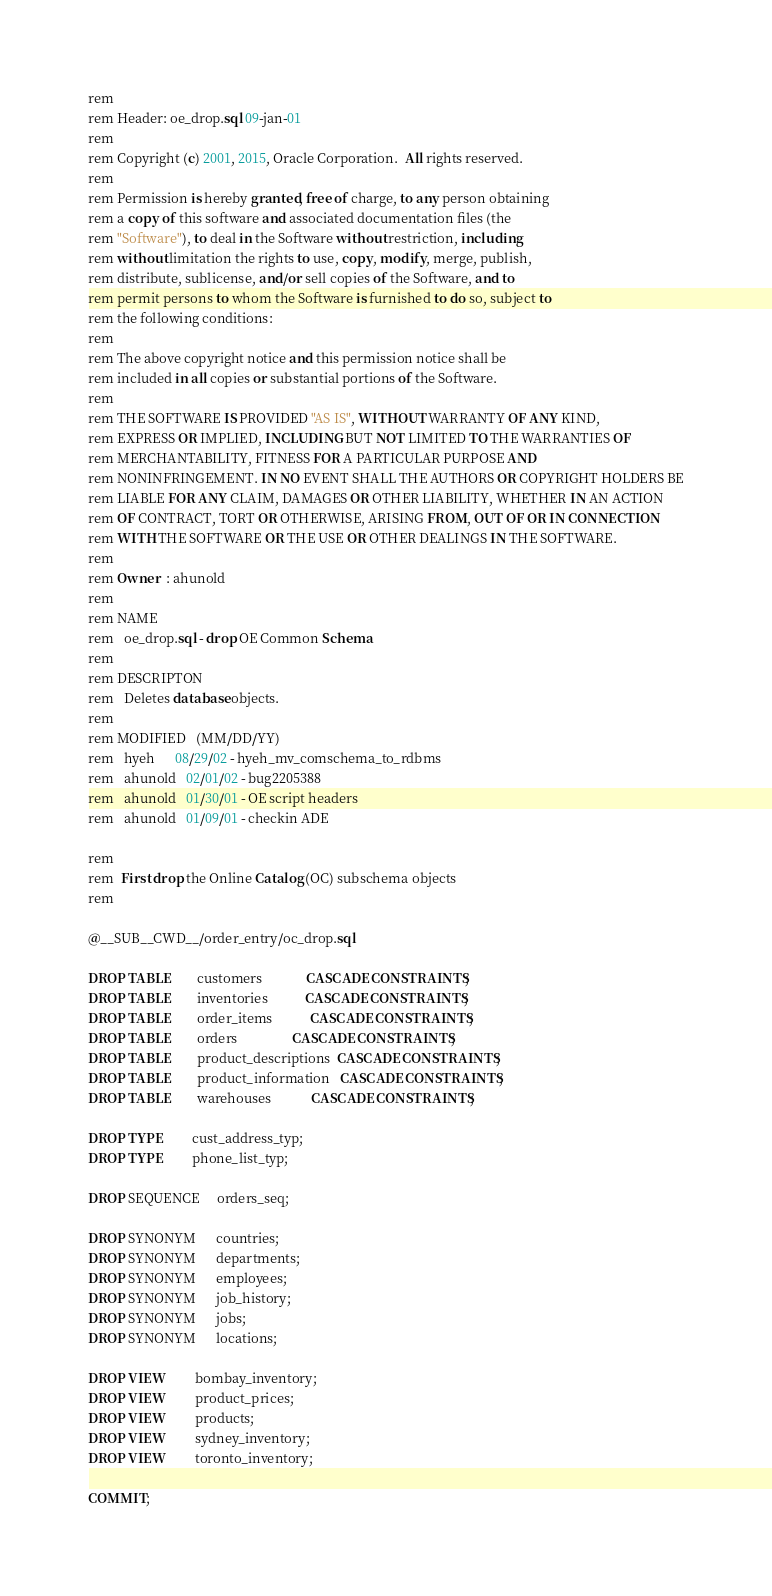Convert code to text. <code><loc_0><loc_0><loc_500><loc_500><_SQL_>rem
rem Header: oe_drop.sql 09-jan-01
rem
rem Copyright (c) 2001, 2015, Oracle Corporation.  All rights reserved.  
rem 
rem Permission is hereby granted, free of charge, to any person obtaining
rem a copy of this software and associated documentation files (the
rem "Software"), to deal in the Software without restriction, including
rem without limitation the rights to use, copy, modify, merge, publish,
rem distribute, sublicense, and/or sell copies of the Software, and to
rem permit persons to whom the Software is furnished to do so, subject to
rem the following conditions:
rem 
rem The above copyright notice and this permission notice shall be
rem included in all copies or substantial portions of the Software.
rem 
rem THE SOFTWARE IS PROVIDED "AS IS", WITHOUT WARRANTY OF ANY KIND,
rem EXPRESS OR IMPLIED, INCLUDING BUT NOT LIMITED TO THE WARRANTIES OF
rem MERCHANTABILITY, FITNESS FOR A PARTICULAR PURPOSE AND
rem NONINFRINGEMENT. IN NO EVENT SHALL THE AUTHORS OR COPYRIGHT HOLDERS BE
rem LIABLE FOR ANY CLAIM, DAMAGES OR OTHER LIABILITY, WHETHER IN AN ACTION
rem OF CONTRACT, TORT OR OTHERWISE, ARISING FROM, OUT OF OR IN CONNECTION
rem WITH THE SOFTWARE OR THE USE OR OTHER DEALINGS IN THE SOFTWARE.
rem
rem Owner  : ahunold
rem
rem NAME
rem   oe_drop.sql - drop OE Common Schema
rem
rem DESCRIPTON
rem   Deletes database objects. 
rem
rem MODIFIED   (MM/DD/YY)
rem   hyeh      08/29/02 - hyeh_mv_comschema_to_rdbms
rem   ahunold   02/01/02 - bug2205388
rem   ahunold   01/30/01 - OE script headers
rem   ahunold   01/09/01 - checkin ADE

rem
rem  First drop the Online Catalog (OC) subschema objects
rem

@__SUB__CWD__/order_entry/oc_drop.sql

DROP TABLE        customers             CASCADE CONSTRAINTS;
DROP TABLE        inventories           CASCADE CONSTRAINTS;
DROP TABLE        order_items           CASCADE CONSTRAINTS;
DROP TABLE        orders                CASCADE CONSTRAINTS;
DROP TABLE        product_descriptions  CASCADE CONSTRAINTS;
DROP TABLE        product_information   CASCADE CONSTRAINTS;
DROP TABLE        warehouses            CASCADE CONSTRAINTS;

DROP TYPE         cust_address_typ;
DROP TYPE         phone_list_typ;

DROP SEQUENCE     orders_seq;

DROP SYNONYM      countries;
DROP SYNONYM      departments;
DROP SYNONYM      employees;
DROP SYNONYM      job_history;
DROP SYNONYM      jobs;
DROP SYNONYM      locations;

DROP VIEW         bombay_inventory;
DROP VIEW         product_prices;
DROP VIEW         products;
DROP VIEW         sydney_inventory;
DROP VIEW         toronto_inventory;

COMMIT;


</code> 